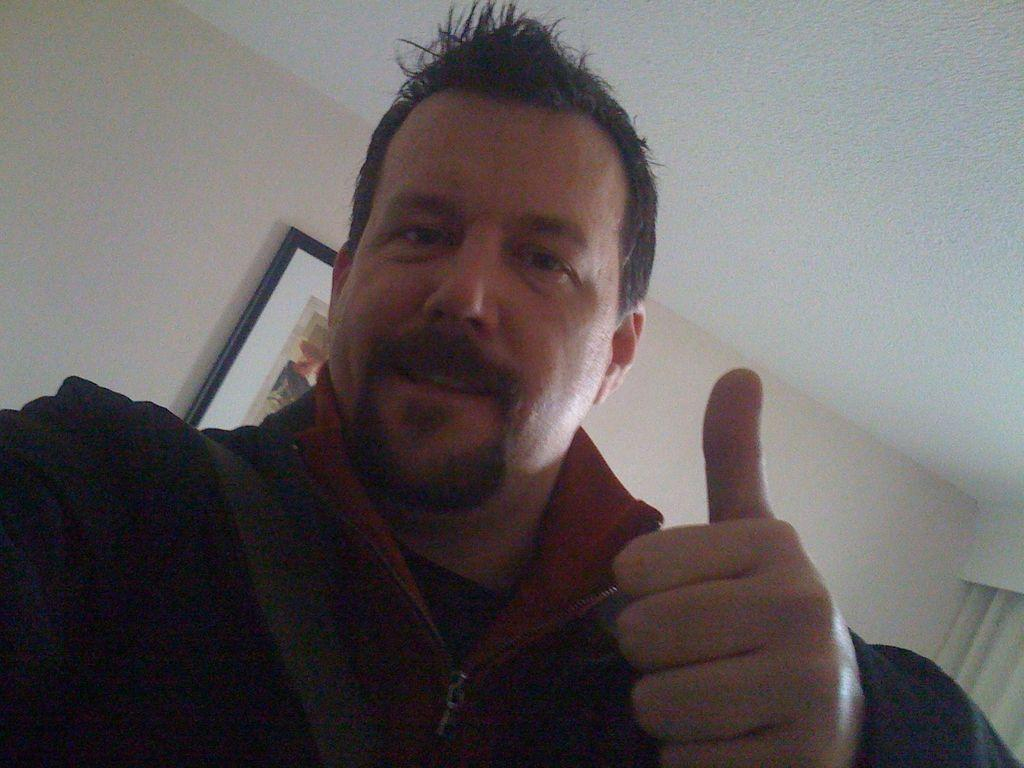Who is present in the image? There is a man in the image. What can be seen on the wall in the image? There is a photo frame on the wall in the image. What is visible in the background of the image? There is a curtain in the background of the image. What type of coal is being used to fuel the man's energy in the image? There is no coal present in the image, and the man's energy is not fueled by coal. 